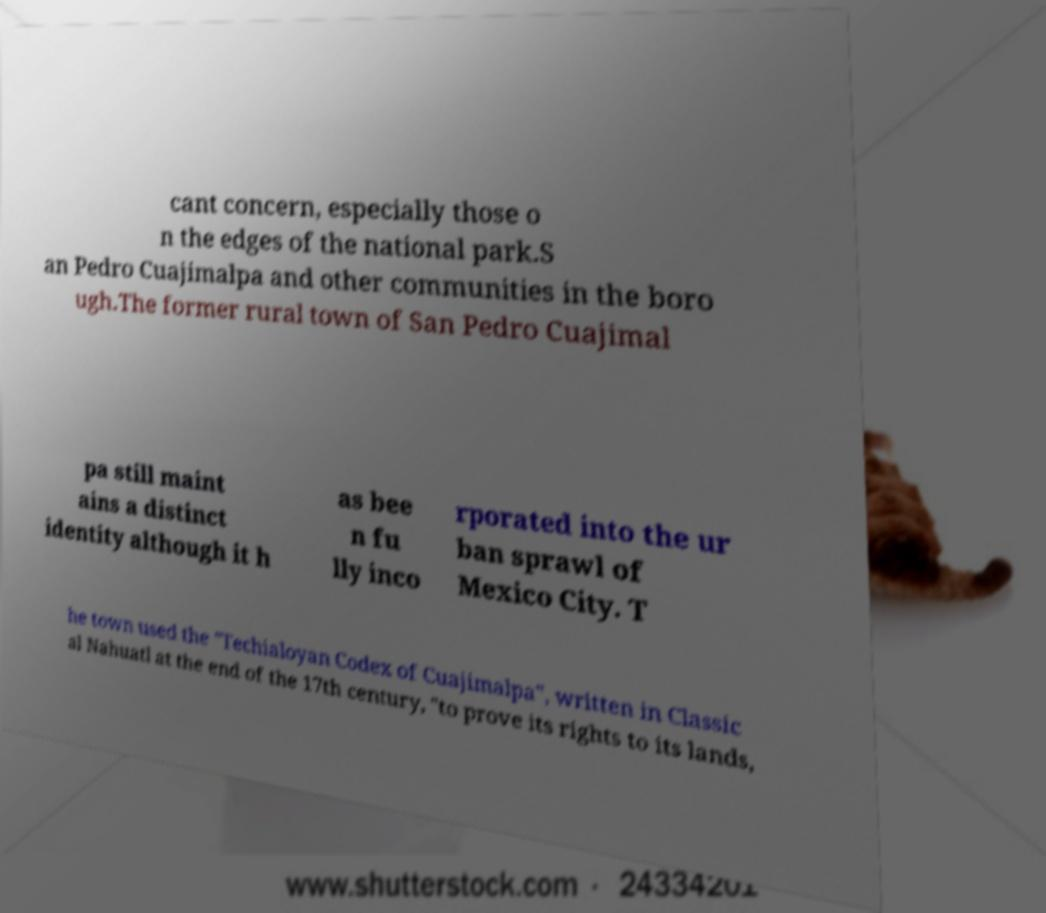Could you extract and type out the text from this image? cant concern, especially those o n the edges of the national park.S an Pedro Cuajimalpa and other communities in the boro ugh.The former rural town of San Pedro Cuajimal pa still maint ains a distinct identity although it h as bee n fu lly inco rporated into the ur ban sprawl of Mexico City. T he town used the "Techialoyan Codex of Cuajimalpa", written in Classic al Nahuatl at the end of the 17th century, "to prove its rights to its lands, 